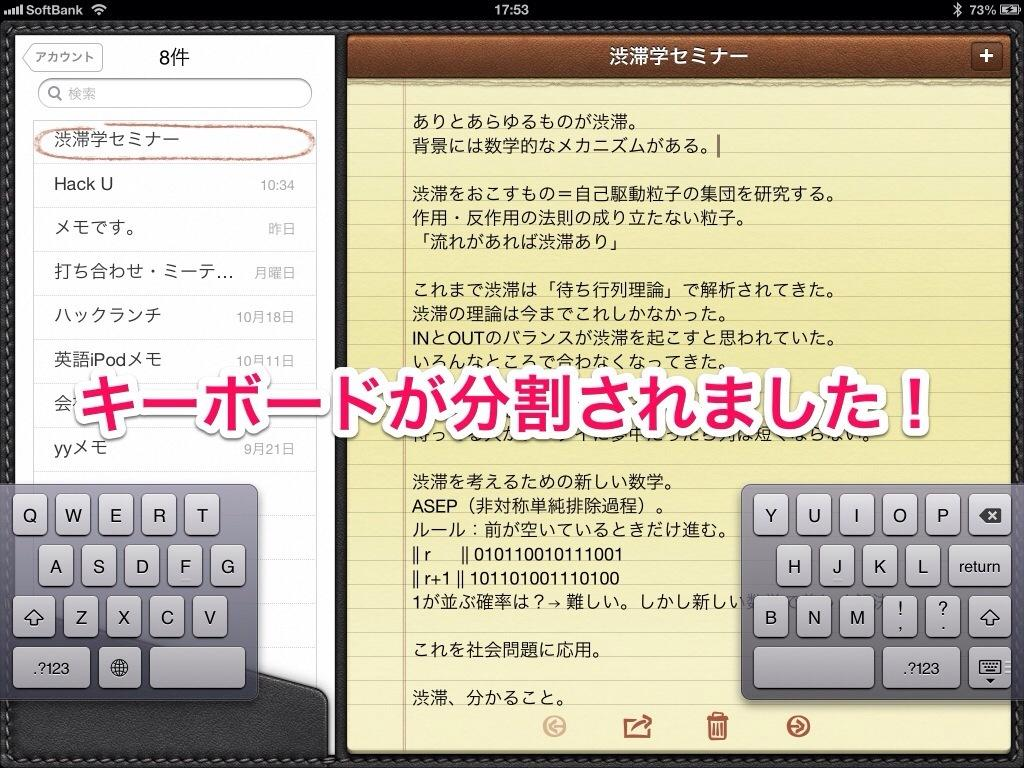<image>
Create a compact narrative representing the image presented. A virtual keyboard on notepad app for Softbank screenshot at 17:53. 